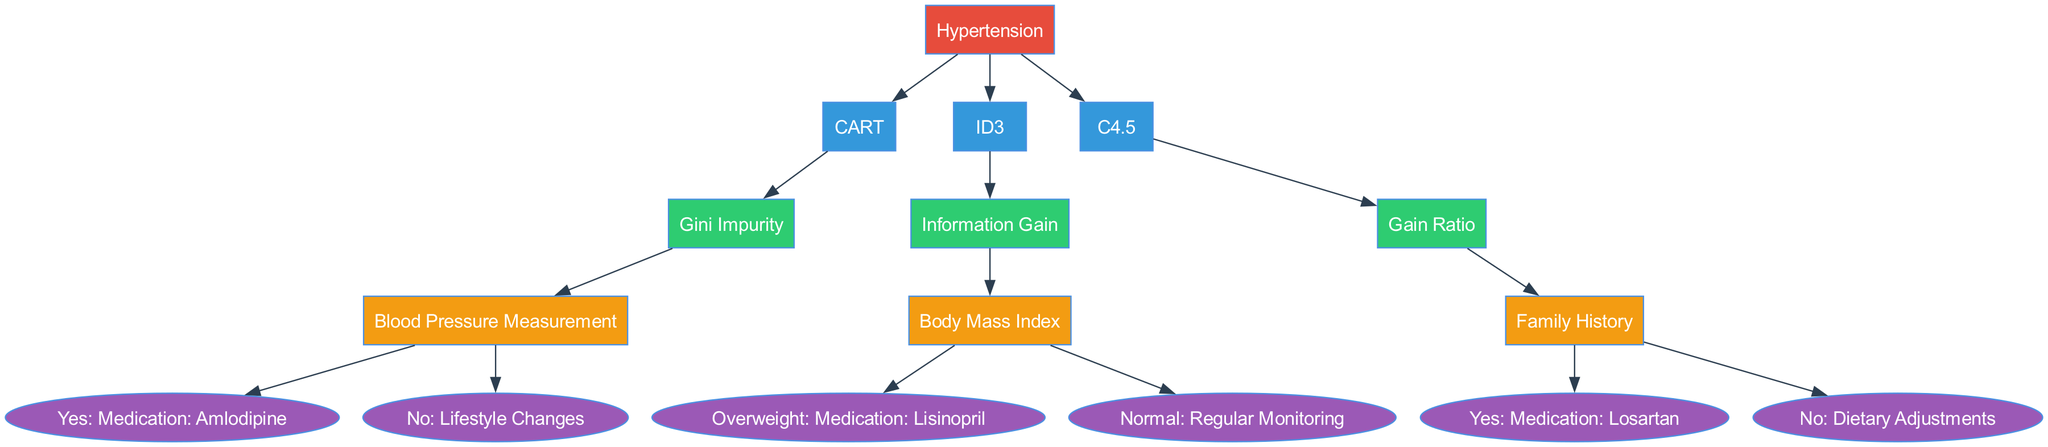What is the root diagnosis in the tree? The root diagnosis is the topmost node in the diagram, which is "Hypertension."
Answer: Hypertension How many algorithms are used in this decision tree? The decision tree contains three algorithms: CART, ID3, and C4.5. This can be counted by identifying the nodes under the root that state different algorithms.
Answer: 3 What criterion does the CART algorithm use? The CART algorithm is associated with the node that states "Gini Impurity." This can be found as a child of the CART algorithm node.
Answer: Gini Impurity If the split is based on "Body Mass Index," which medication is recommended for overweight individuals? If "Body Mass Index" is the split and the condition is "Overweight," the recommended medication will be "Medication: Lisinopril." This is specified as the leaf node related to that condition.
Answer: Medication: Lisinopril What dietary recommendation follows the split of "Family History" under C4.5 for individuals with no family history? For individuals with "No" family history, the recommendation provided at the leaf node is "Dietary Adjustments." This can be traced from the C4.5 algorithm down to the leaf node for that split.
Answer: Dietary Adjustments Which algorithm follows the root diagnosis and uses "Information Gain" as its criterion? The decision tree shows that the algorithm following the root diagnosis that uses "Information Gain" is ID3. This can be determined by following the branches under the root node to the algorithms.
Answer: ID3 How many terminal nodes (leaf nodes) are present in the tree? The terminal nodes can be counted by identifying the final results after each split in the diagram. In this case, there are five terminal nodes: "Medication: Amlodipine," "Lifestyle Changes," "Medication: Lisinopril," "Regular Monitoring," "Medication: Losartan," and "Dietary Adjustments."
Answer: 6 Which algorithm recommends "Lifestyle Changes" for low blood pressure measurements? The recommendation of "Lifestyle Changes" follows the CART algorithm when "Blood Pressure Measurement" yields a "No" response. This conclusion can be reached by tracking the branches back to the CART section.
Answer: CART In the C4.5 algorithm, what is the decision based on the "Family History" split if the answer is "Yes"? For "Yes" on the "Family History" split in the C4.5 algorithm, the recommendation is "Medication: Losartan." This can be seen directly at the leaf node connected to that decision branch.
Answer: Medication: Losartan 